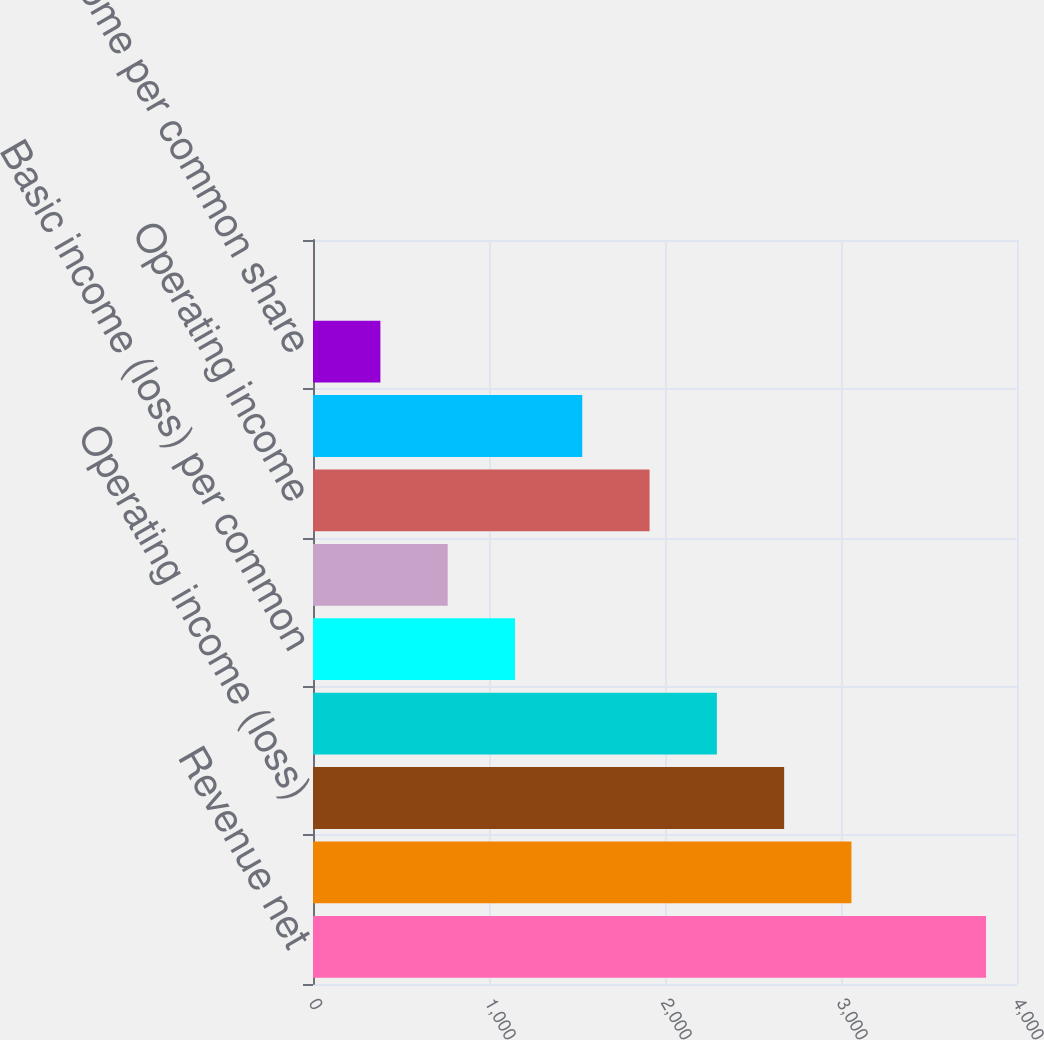<chart> <loc_0><loc_0><loc_500><loc_500><bar_chart><fcel>Revenue net<fcel>Gross profit<fcel>Operating income (loss)<fcel>Net income (loss)<fcel>Basic income (loss) per common<fcel>Diluted income (loss) per<fcel>Operating income<fcel>Net income<fcel>Basic income per common share<fcel>Diluted income per common<nl><fcel>3824<fcel>3059.33<fcel>2676.99<fcel>2294.65<fcel>1147.63<fcel>765.29<fcel>1912.31<fcel>1529.97<fcel>382.95<fcel>0.61<nl></chart> 